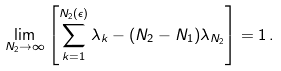<formula> <loc_0><loc_0><loc_500><loc_500>\lim _ { N _ { 2 } \rightarrow \infty } \left [ \sum _ { k = 1 } ^ { N _ { 2 } ( \epsilon ) } \lambda _ { k } - ( N _ { 2 } - N _ { 1 } ) \lambda _ { N _ { 2 } } \right ] = 1 \, .</formula> 